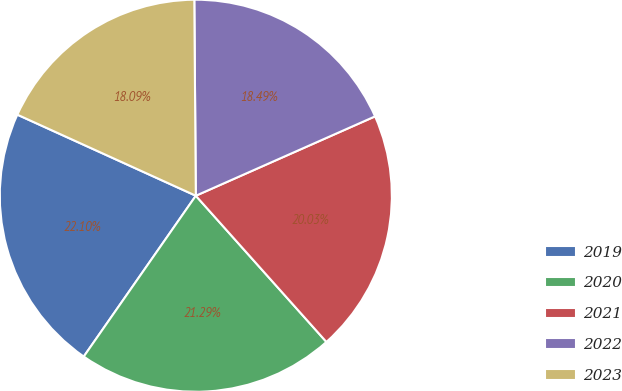Convert chart. <chart><loc_0><loc_0><loc_500><loc_500><pie_chart><fcel>2019<fcel>2020<fcel>2021<fcel>2022<fcel>2023<nl><fcel>22.1%<fcel>21.29%<fcel>20.03%<fcel>18.49%<fcel>18.09%<nl></chart> 